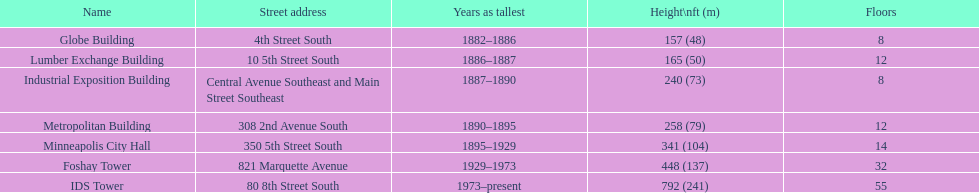Which was the foremost edifice identified as the tallest? Globe Building. 